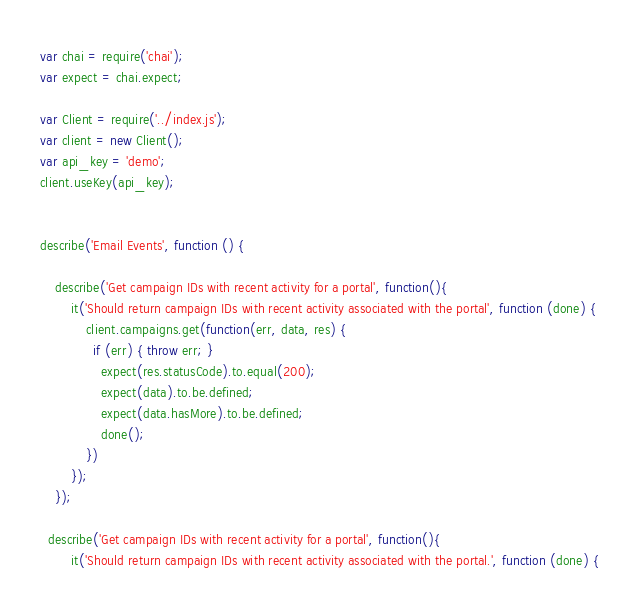<code> <loc_0><loc_0><loc_500><loc_500><_JavaScript_>var chai = require('chai');
var expect = chai.expect;

var Client = require('../index.js');
var client = new Client();
var api_key = 'demo';
client.useKey(api_key);


describe('Email Events', function () {

	describe('Get campaign IDs with recent activity for a portal', function(){
		it('Should return campaign IDs with recent activity associated with the portal', function (done) {
			client.campaigns.get(function(err, data, res) {
			  if (err) { throw err; }
				expect(res.statusCode).to.equal(200);
				expect(data).to.be.defined;
				expect(data.hasMore).to.be.defined;
				done();
			})
		});
	});

  describe('Get campaign IDs with recent activity for a portal', function(){
		it('Should return campaign IDs with recent activity associated with the portal.', function (done) {</code> 